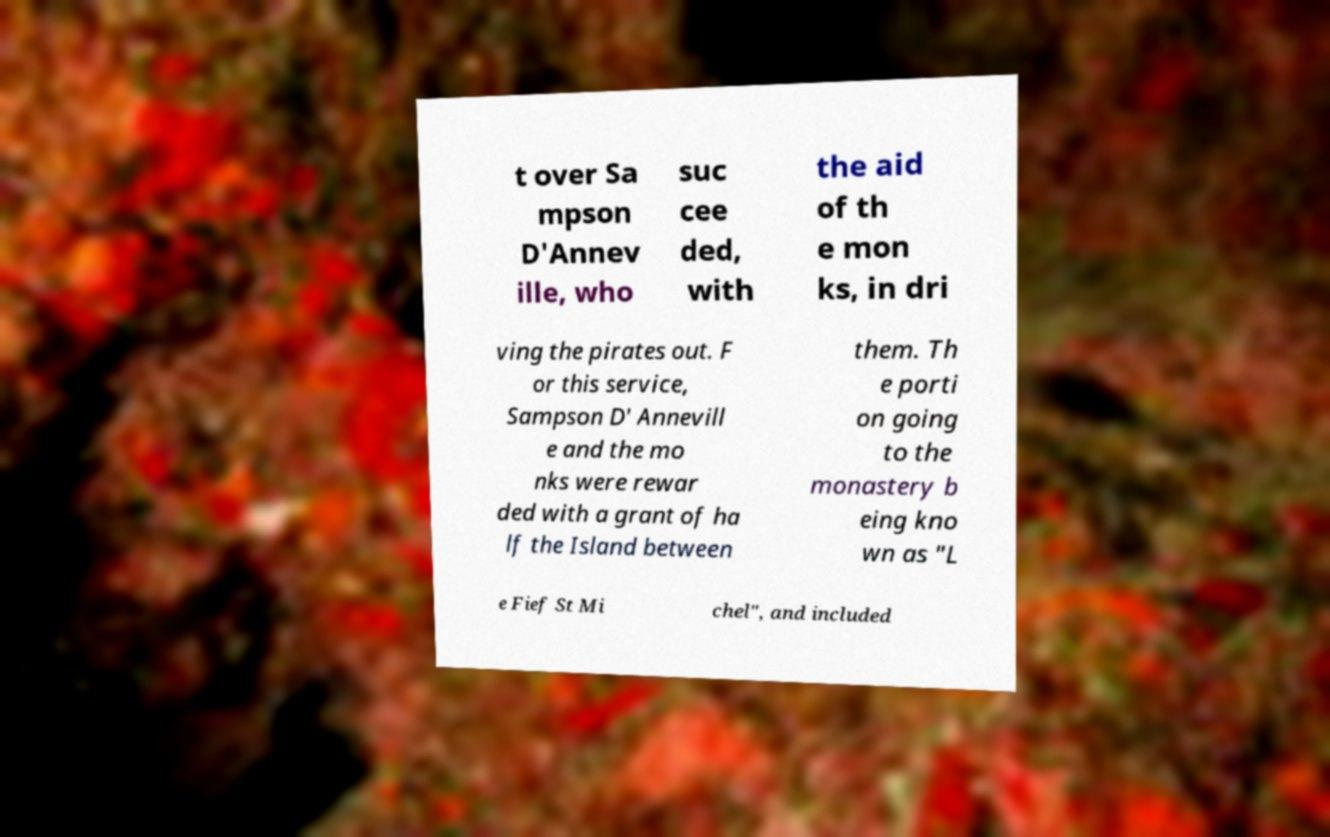Could you extract and type out the text from this image? t over Sa mpson D'Annev ille, who suc cee ded, with the aid of th e mon ks, in dri ving the pirates out. F or this service, Sampson D' Annevill e and the mo nks were rewar ded with a grant of ha lf the Island between them. Th e porti on going to the monastery b eing kno wn as "L e Fief St Mi chel", and included 